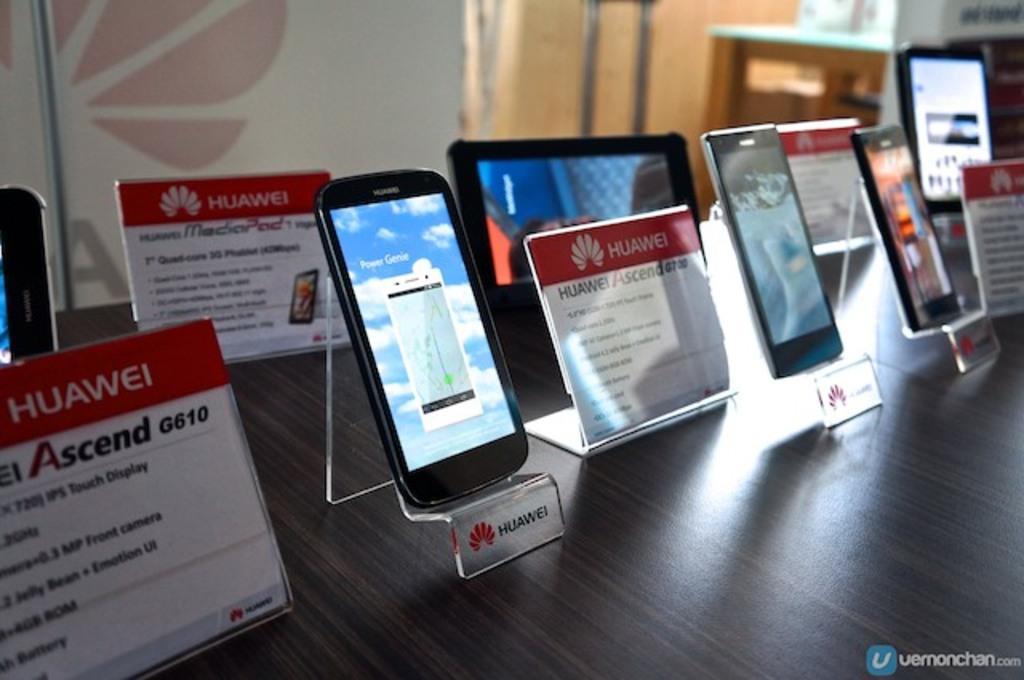<image>
Give a short and clear explanation of the subsequent image. A display of many Huawei phones and tablets. 